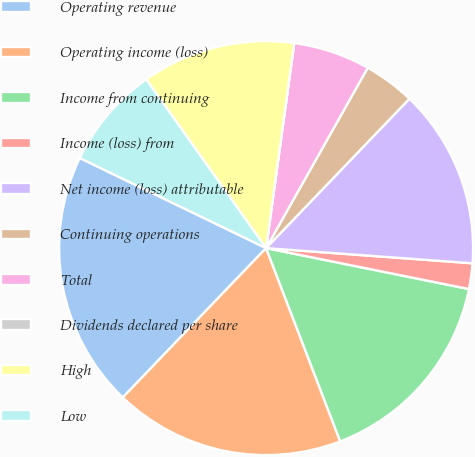<chart> <loc_0><loc_0><loc_500><loc_500><pie_chart><fcel>Operating revenue<fcel>Operating income (loss)<fcel>Income from continuing<fcel>Income (loss) from<fcel>Net income (loss) attributable<fcel>Continuing operations<fcel>Total<fcel>Dividends declared per share<fcel>High<fcel>Low<nl><fcel>20.0%<fcel>18.0%<fcel>16.0%<fcel>2.0%<fcel>14.0%<fcel>4.0%<fcel>6.0%<fcel>0.0%<fcel>12.0%<fcel>8.0%<nl></chart> 